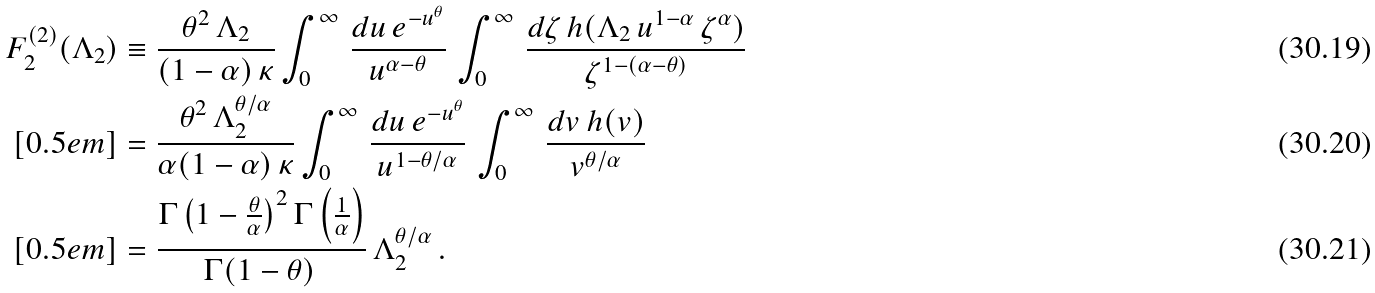Convert formula to latex. <formula><loc_0><loc_0><loc_500><loc_500>F _ { 2 } ^ { ( 2 ) } ( \Lambda _ { 2 } ) & \equiv \frac { \theta ^ { 2 } \, \Lambda _ { 2 } } { ( 1 - \alpha ) \, \kappa } \int _ { 0 } ^ { \infty } \, \frac { d u \, e ^ { - u ^ { \theta } } } { u ^ { \alpha - \theta } } \, \int _ { 0 } ^ { \infty } \, \frac { d \zeta \, h ( \Lambda _ { 2 } \, u ^ { 1 - \alpha } \, \zeta ^ { \alpha } ) } { \zeta ^ { 1 - ( \alpha - \theta ) } } \\ [ 0 . 5 e m ] & = \frac { \theta ^ { 2 } \, \Lambda _ { 2 } ^ { \theta / \alpha } } { \alpha ( 1 - \alpha ) \, \kappa } \int _ { 0 } ^ { \infty } \, \frac { d u \, e ^ { - u ^ { \theta } } } { u ^ { 1 - \theta / \alpha } } \, \int _ { 0 } ^ { \infty } \, \frac { d v \, h ( v ) } { v ^ { \theta / \alpha } } \\ [ 0 . 5 e m ] & = \frac { \Gamma \left ( 1 - \frac { \theta } { \alpha } \right ) ^ { 2 } \Gamma \left ( \frac { 1 } { \alpha } \right ) } { \Gamma ( 1 - \theta ) \, } \, \Lambda _ { 2 } ^ { \theta / \alpha } \, .</formula> 